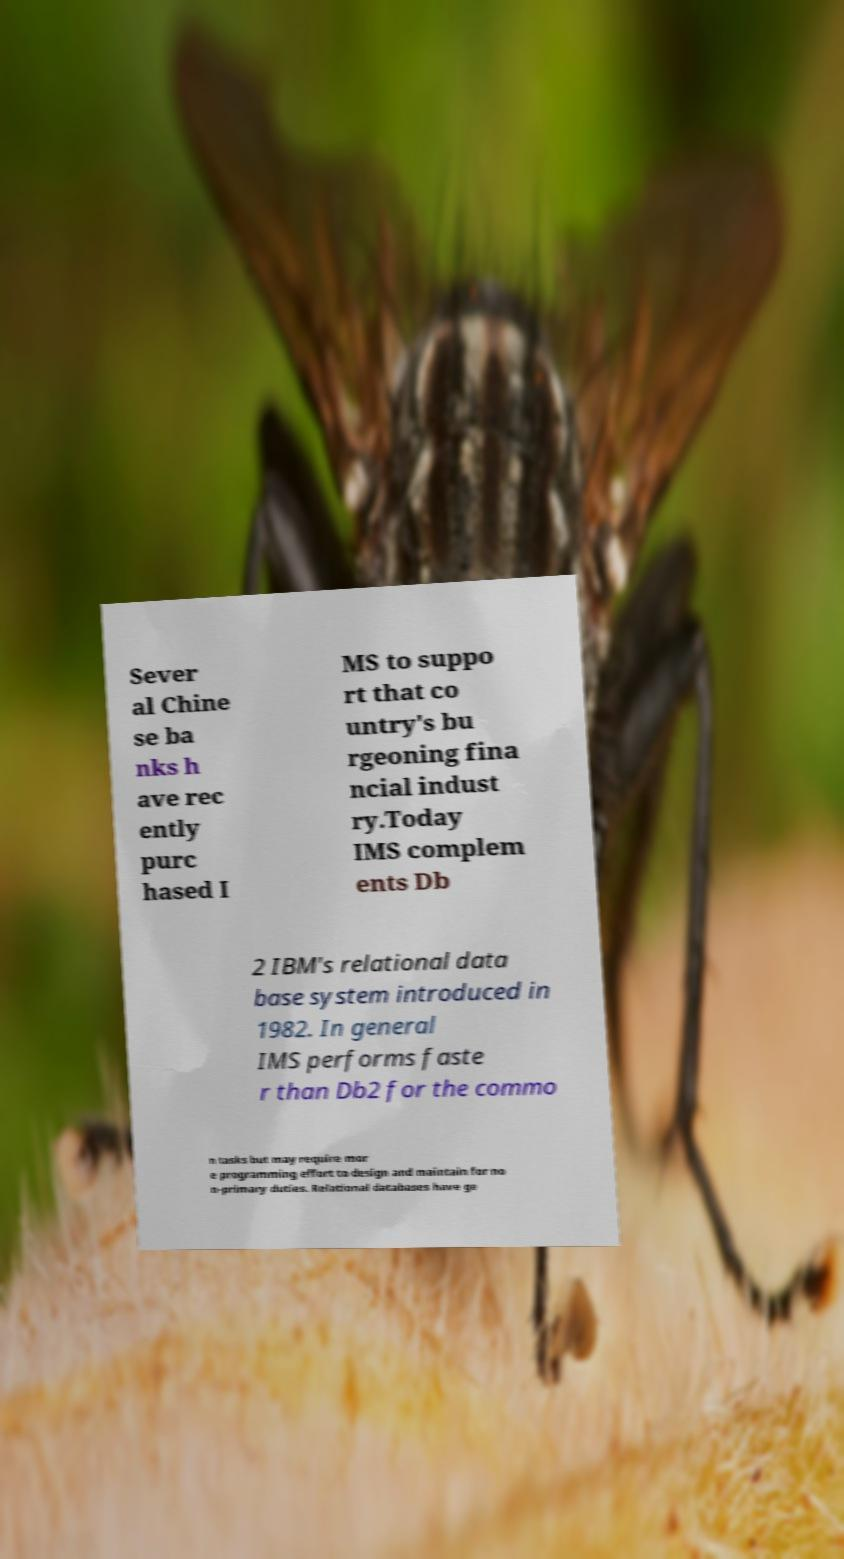Can you read and provide the text displayed in the image?This photo seems to have some interesting text. Can you extract and type it out for me? Sever al Chine se ba nks h ave rec ently purc hased I MS to suppo rt that co untry's bu rgeoning fina ncial indust ry.Today IMS complem ents Db 2 IBM's relational data base system introduced in 1982. In general IMS performs faste r than Db2 for the commo n tasks but may require mor e programming effort to design and maintain for no n-primary duties. Relational databases have ge 